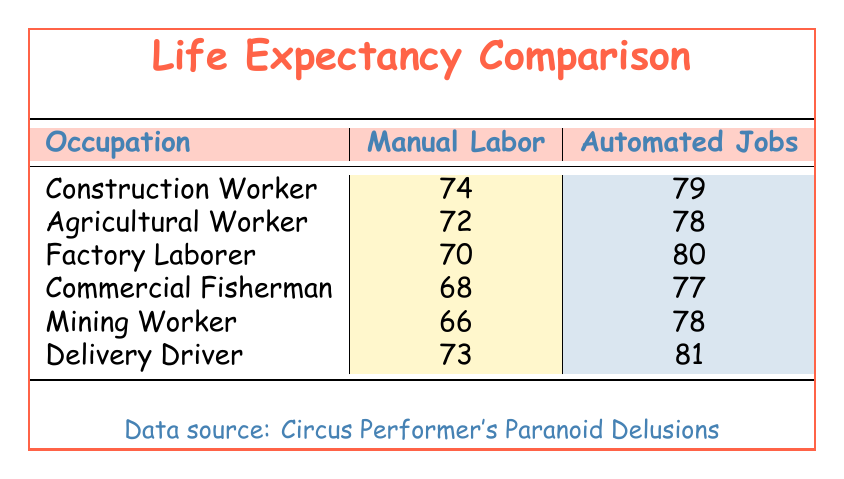What is the life expectancy for Construction Workers in manual labor? The table directly states that the life expectancy for Construction Workers in manual labor is 74 years.
Answer: 74 What is the life expectancy of Delivery Drivers in automated jobs? According to the table, the life expectancy for Delivery Drivers in automated jobs is 81 years.
Answer: 81 Which occupation has the highest life expectancy in automated jobs? By reviewing the automated jobs column, the Factory Laborer has the highest life expectancy of 80 years compared to others.
Answer: Factory Laborer Is the life expectancy for Agricultural Workers in manual labor greater than that of Mining Workers in manual labor? The table shows that Agricultural Workers have a manual labor life expectancy of 72 years, while Mining Workers have 66 years. Since 72 is greater than 66, the statement is true.
Answer: Yes What is the difference in life expectancy between Factory Laborers in manual labor and Construction Workers in manual labor? The life expectancy for Factory Laborers in manual labor is 70 years, and for Construction Workers, it is 74 years. The difference is calculated as 74 - 70 = 4 years.
Answer: 4 If we consider both manual laborers and automated jobs, what is the average life expectancy for Commercial Fishermen? For Commercial Fishermen, the manual labor life expectancy is 68 years and the automated jobs life expectancy is 77 years. To find the average, we sum them (68 + 77 = 145) and divide by 2, resulting in 145/2 = 72.5 years.
Answer: 72.5 Are manual laborers in all occupations listed having a lower life expectancy than their counterparts in automated jobs? By evaluating the life expectancies, Construction Workers, Agricultural Workers, and Delivery Drivers have lower life expectancies in manual labor than their automated counterparts. However, Mining Workers have the same life expectancy (66 years) for manual labor and automated jobs. Thus, the statement is false.
Answer: No What is the lowest life expectancy among manual laborers listed in the table? The table reveals that the lowest life expectancy among manual laborers is 66 years for Mining Workers.
Answer: 66 What is the average life expectancy of manual laborers across all listed occupations? The manual labor life expectancies are 74, 72, 70, 68, 66, and 73 years. Summing these gives 74 + 72 + 70 + 68 + 66 + 73 = 423. The average is calculated by dividing 423 by 6, which results in 70.5 years.
Answer: 70.5 